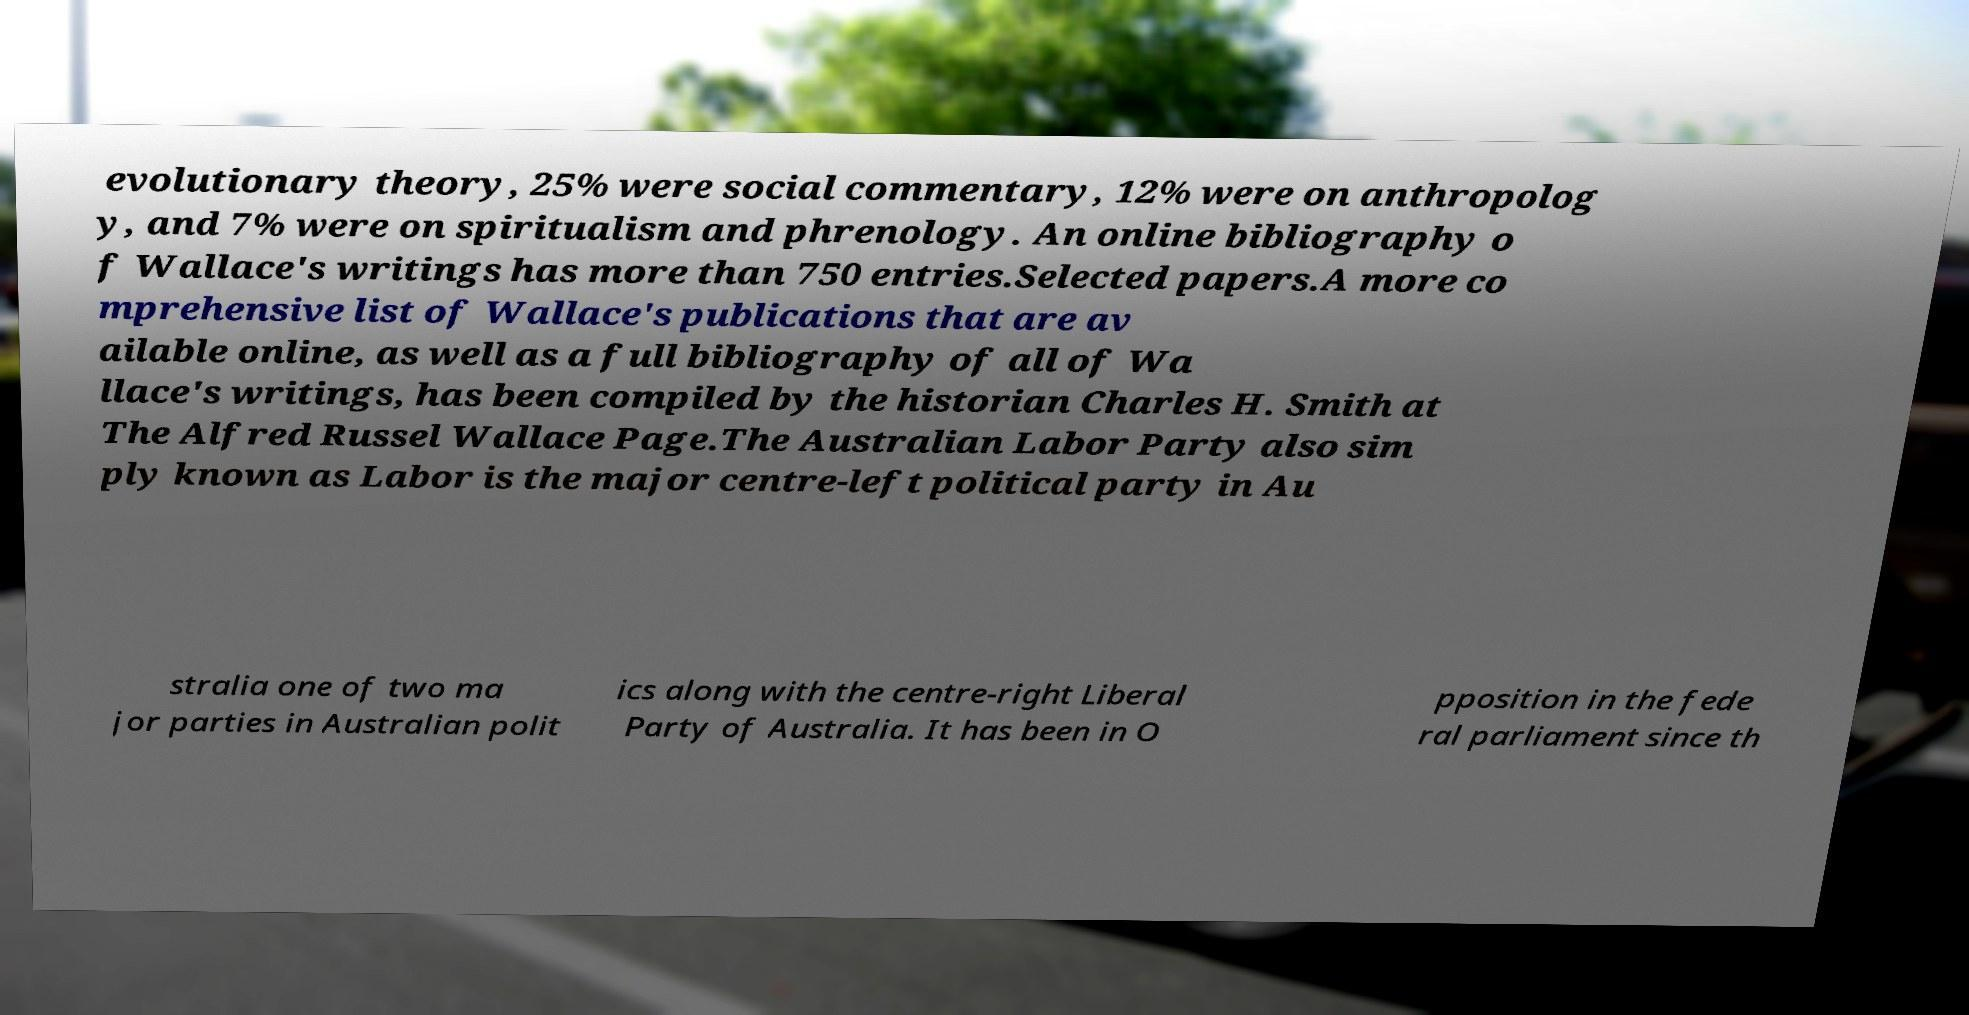Can you read and provide the text displayed in the image?This photo seems to have some interesting text. Can you extract and type it out for me? evolutionary theory, 25% were social commentary, 12% were on anthropolog y, and 7% were on spiritualism and phrenology. An online bibliography o f Wallace's writings has more than 750 entries.Selected papers.A more co mprehensive list of Wallace's publications that are av ailable online, as well as a full bibliography of all of Wa llace's writings, has been compiled by the historian Charles H. Smith at The Alfred Russel Wallace Page.The Australian Labor Party also sim ply known as Labor is the major centre-left political party in Au stralia one of two ma jor parties in Australian polit ics along with the centre-right Liberal Party of Australia. It has been in O pposition in the fede ral parliament since th 